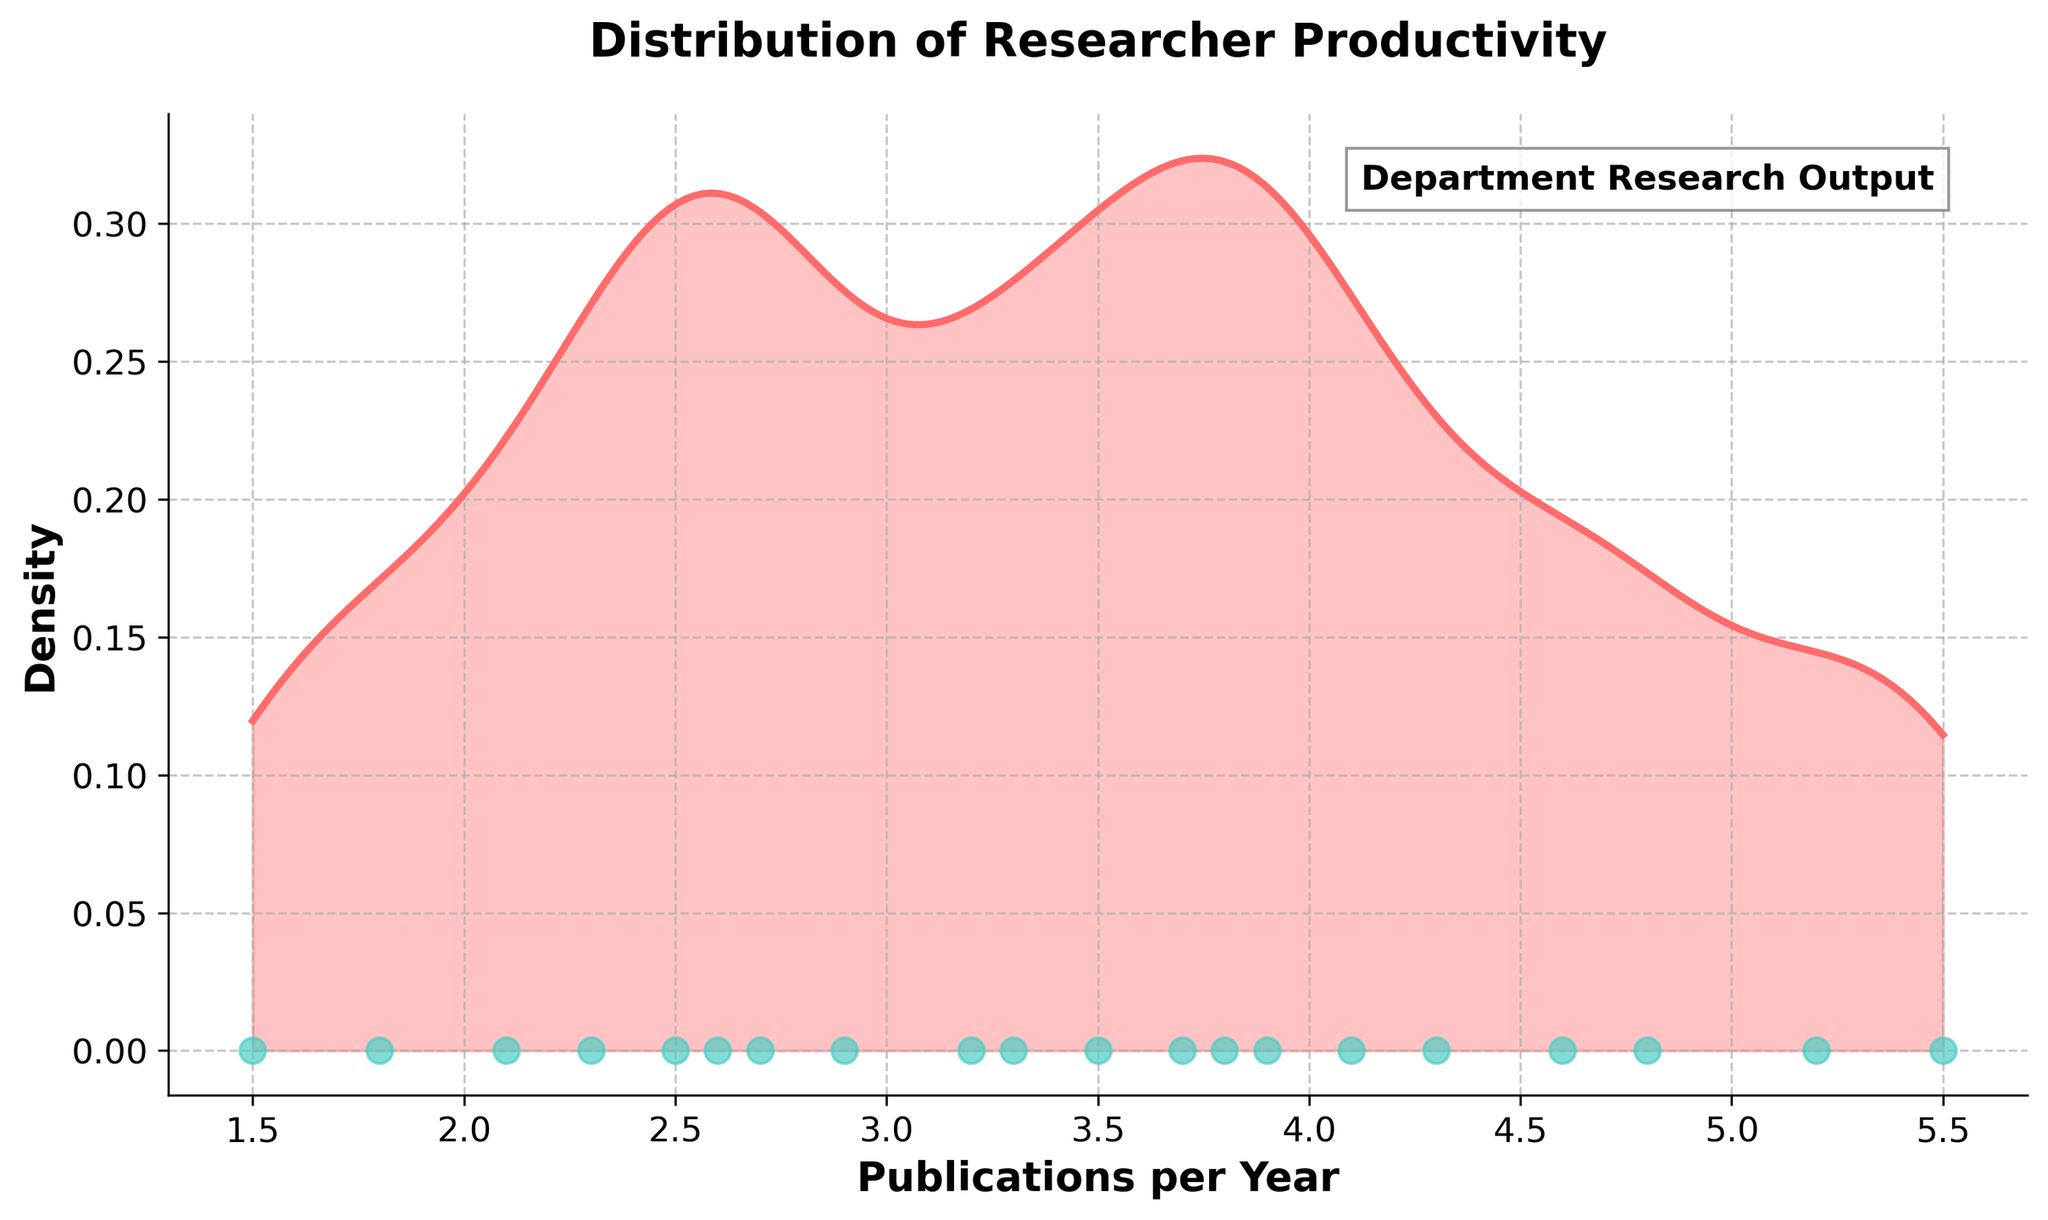What is the title of the density plot? The title is located at the top of the figure and prominently displayed.
Answer: Distribution of Researcher Productivity What is the x-axis label of the density plot? The x-axis label is the text next to the horizontal axis at the bottom of the plot.
Answer: Publications per Year How many publications per year does Dr. Sophia Anderson have? By identifying the scatter point corresponding to Dr. Sophia Anderson on the x-axis and referencing the original data, it is clear she has 5.5 publications per year.
Answer: 5.5 Which researcher has the highest number of publications per year and what is that number? Locate the highest scatter point on the x-axis and verify with the data. Dr. Sophia Anderson has the highest publications per year.
Answer: Dr. Sophia Anderson, 5.5 What is the lowest number of publications per year observed among the researchers? Find the leftmost scatter point on the x-axis which represents the minimum value.
Answer: 1.5 What color is used to represent the density in the plot? The density is represented by a solid color line and filled area in the plot.
Answer: A shade of red (description inferred without specific coding details) What is the estimated peak density value in the plot? Identify the highest point in the density curve which indicates the peak density value.
Answer: Answer would be an approximate observation (e.g., 0.25), best judged visually from the plot What is the range of publications per year among the researchers? Calculate the difference between the maximum and minimum values (5.5 - 1.5).
Answer: 4.0 Which area has the highest density of publications per year? The peak of the density curve shows the value with the highest number of researchers having publications within that range.
Answer: Around 3 publications per year Compare the publication productivity of Dr. Robert Taylor and Dr. Olivia Nguyen. Who is more productive? Locate both scatter points on the x-axis and compare their positions. Dr. Robert Taylor has 4.8, and Dr. Olivia Nguyen has 3.2, meaning Dr. Robert Taylor is more productive.
Answer: Dr. Robert Taylor What is the general trend of the density curve? Observe the shape of the curve—how it starts, peaks, and then declines.
Answer: The density curve starts low, peaks around 3 publications, and then declines 